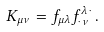Convert formula to latex. <formula><loc_0><loc_0><loc_500><loc_500>K _ { \mu \nu } = f _ { \mu \lambda } f ^ { \lambda \, \cdot } _ { \cdot \, \nu } \, .</formula> 